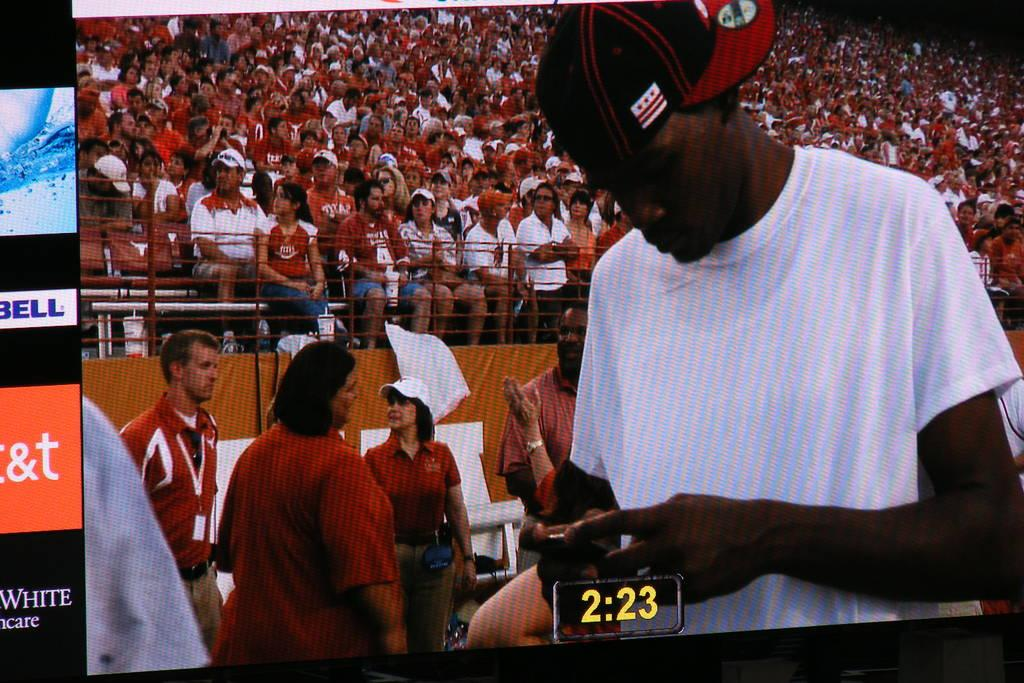<image>
Create a compact narrative representing the image presented. The parts of the signs on the right are for Taco Bell and AT&T. 